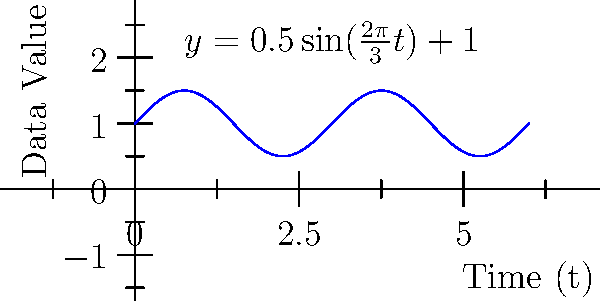In an AI algorithm for time series analysis, you encounter a periodic pattern in the data that can be modeled using the trigonometric function $y = 0.5\sin(\frac{2\pi}{3}t) + 1$, where $t$ represents time in days. What is the period of this function, and how would you interpret this in the context of AI-driven data analysis? To find the period of the given trigonometric function and interpret its meaning in AI-driven data analysis, we'll follow these steps:

1) The general form of a sine function is $y = A\sin(B(x-C)) + D$, where:
   - $A$ is the amplitude
   - $B$ is related to the period
   - $C$ is the phase shift
   - $D$ is the vertical shift

2) In our case, $y = 0.5\sin(\frac{2\pi}{3}t) + 1$, so $B = \frac{2\pi}{3}$

3) The period of a sine function is given by the formula: $\text{Period} = \frac{2\pi}{|B|}$

4) Substituting our $B$ value:
   $\text{Period} = \frac{2\pi}{|\frac{2\pi}{3}|} = \frac{2\pi}{\frac{2\pi}{3}} = 3$

5) Therefore, the period of the function is 3 days.

6) In the context of AI-driven data analysis:
   - This means the pattern in the data repeats every 3 days.
   - The AI algorithm can use this information to make predictions about future data points.
   - It can help in feature engineering, where periodic features with a 3-day cycle might be created.
   - Anomaly detection algorithms can use this to identify deviations from the expected 3-day pattern.
   - Time series forecasting models can incorporate this 3-day periodicity to improve accuracy.
Answer: 3 days; pattern repeats every 3 days, aiding in predictions, feature engineering, and anomaly detection in AI algorithms. 